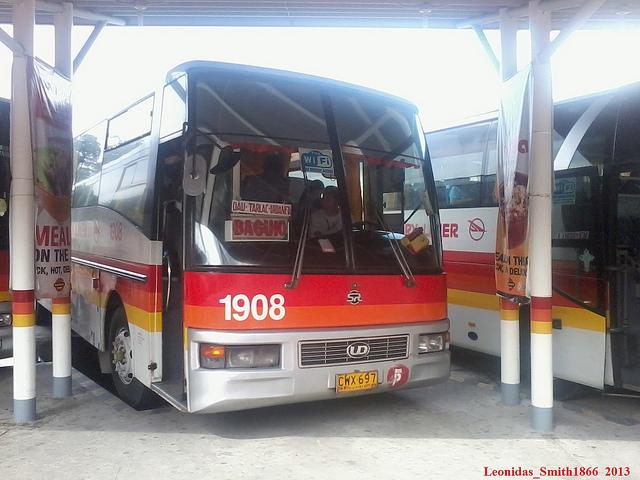What is the bus number?
Give a very brief answer. 1908. Is this a bus depot?
Concise answer only. Yes. Is this a train station?
Answer briefly. No. 